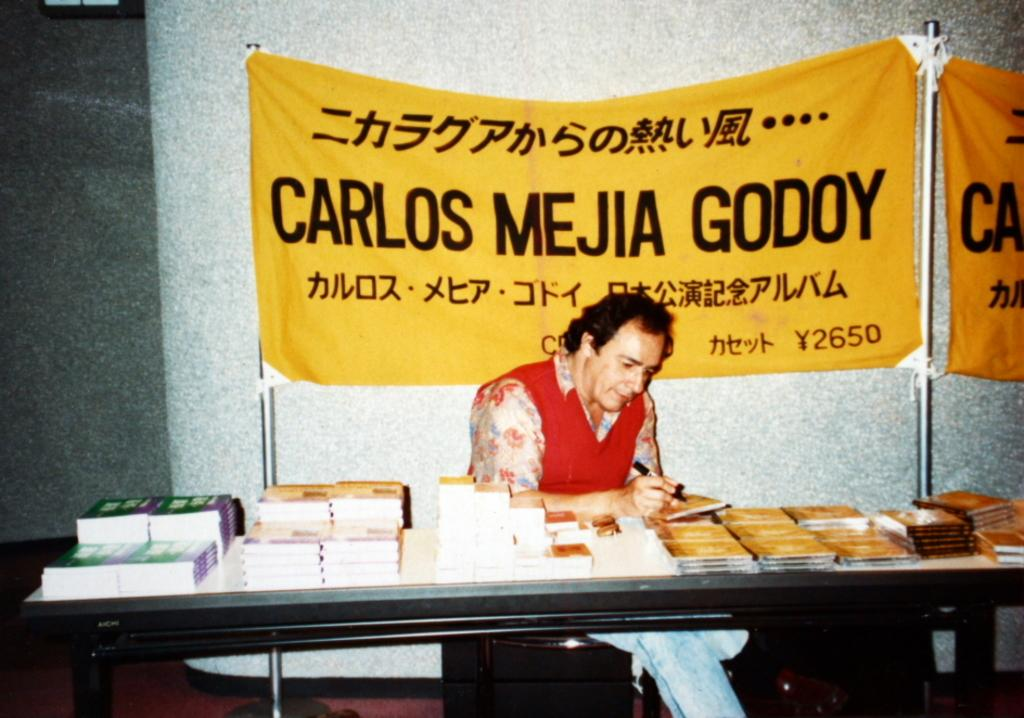What is the person in the image doing? The person is sitting in front of a table. What objects can be seen on the table? There are books placed on the table. Is there anything else on the table besides the books? Yes, there is a banner placed on the back side of the table. Reasoning: Let' Let's think step by step in order to produce the conversation. We start by identifying the main subject in the image, which is the person sitting in front of the table. Then, we expand the conversation to include other items that are also visible on the table, such as the books and the banner. Each question is designed to elicit a specific detail about the image that is known from the provided facts. Absurd Question/Answer: What type of calculator is being used by the person in the image? There is no calculator present in the image. How many rolls of paper are visible on the table? There are no rolls of paper visible in the image. 